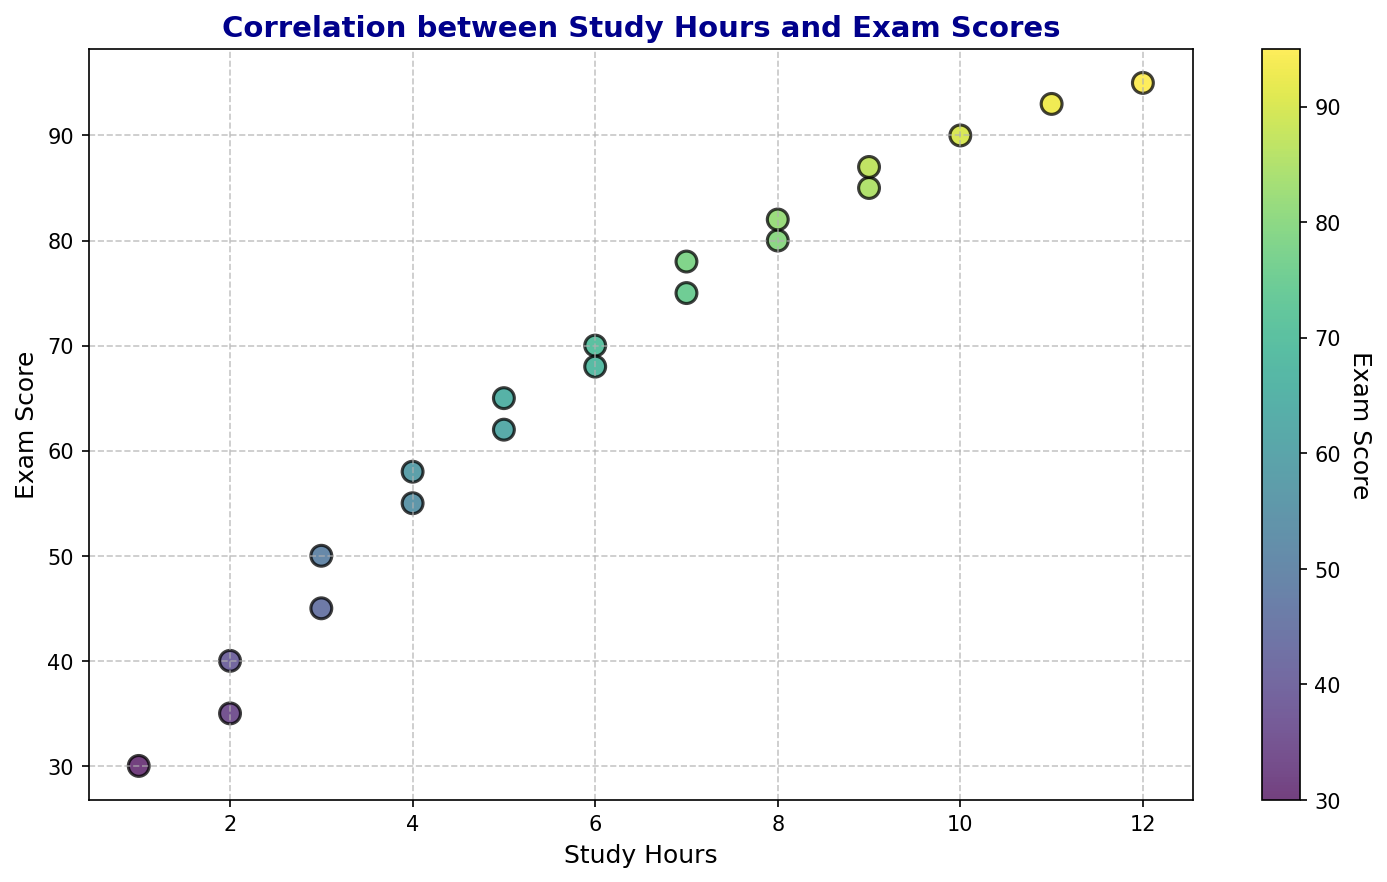How many hours of study correspond to the highest exam score? By inspecting the scatter plot, we find the highest exam score (95). The data point corresponding to the highest score shows a study time of 12 hours.
Answer: 12 hours Which student (based on study hours) scored the lowest on the exam? The lowest exam score (30) in the scatter plot corresponds to the student who studied for 1 hour.
Answer: 1 hour What is the average exam score for students who studied exactly 9 hours? Check the scatter plot for data points where study hours are 9, corresponding exam scores are 85 and 87. Calculate the average: (85 + 87) / 2 = 86
Answer: 86 Which ranges of study hours (least and most study hours) show a relatively smooth increase in exam scores with study hours? In the scatter plot, from 1 to 5 study hours (scores from 30 to 65) and from 6 to 10 study hours (scores from 68 to 90) show smoother upward trends.
Answer: 1-5 and 6-10 hours Is there a visible trend between study hours and exam scores? Observing the scatter plot, we notice a general upward trend, indicating that exam scores tend to increase with the number of study hours.
Answer: Yes, upward trend What color range is used to indicate higher exam scores in the scatter plot? Higher scores are represented by brighter colors in the color bar, shifting towards green and yellow, while lower scores are darker green and blue.
Answer: Green and yellow Which two data points have the smallest difference in exam scores given the same study hours? Look for points with the same study hours and closest exam scores. Both students who studied 6 hours have scores 70 and 68.
Answer: 70 and 68 Are there any outlier points where students scored exceptionally high or low compared to their peers with similar study hours? The score of 95 for 12 study hours and the score of 30 for 1 study hour might be considered outliers, as they are notably distinct from their peers.
Answer: Yes, 12 hours (95) and 1 hour (30) Which study hour has the most data points in the scatter plot? Looking at the scatter plot, the study hour with the highest frequency is 6 hours, showing up twice in the plot.
Answer: 6 hours 